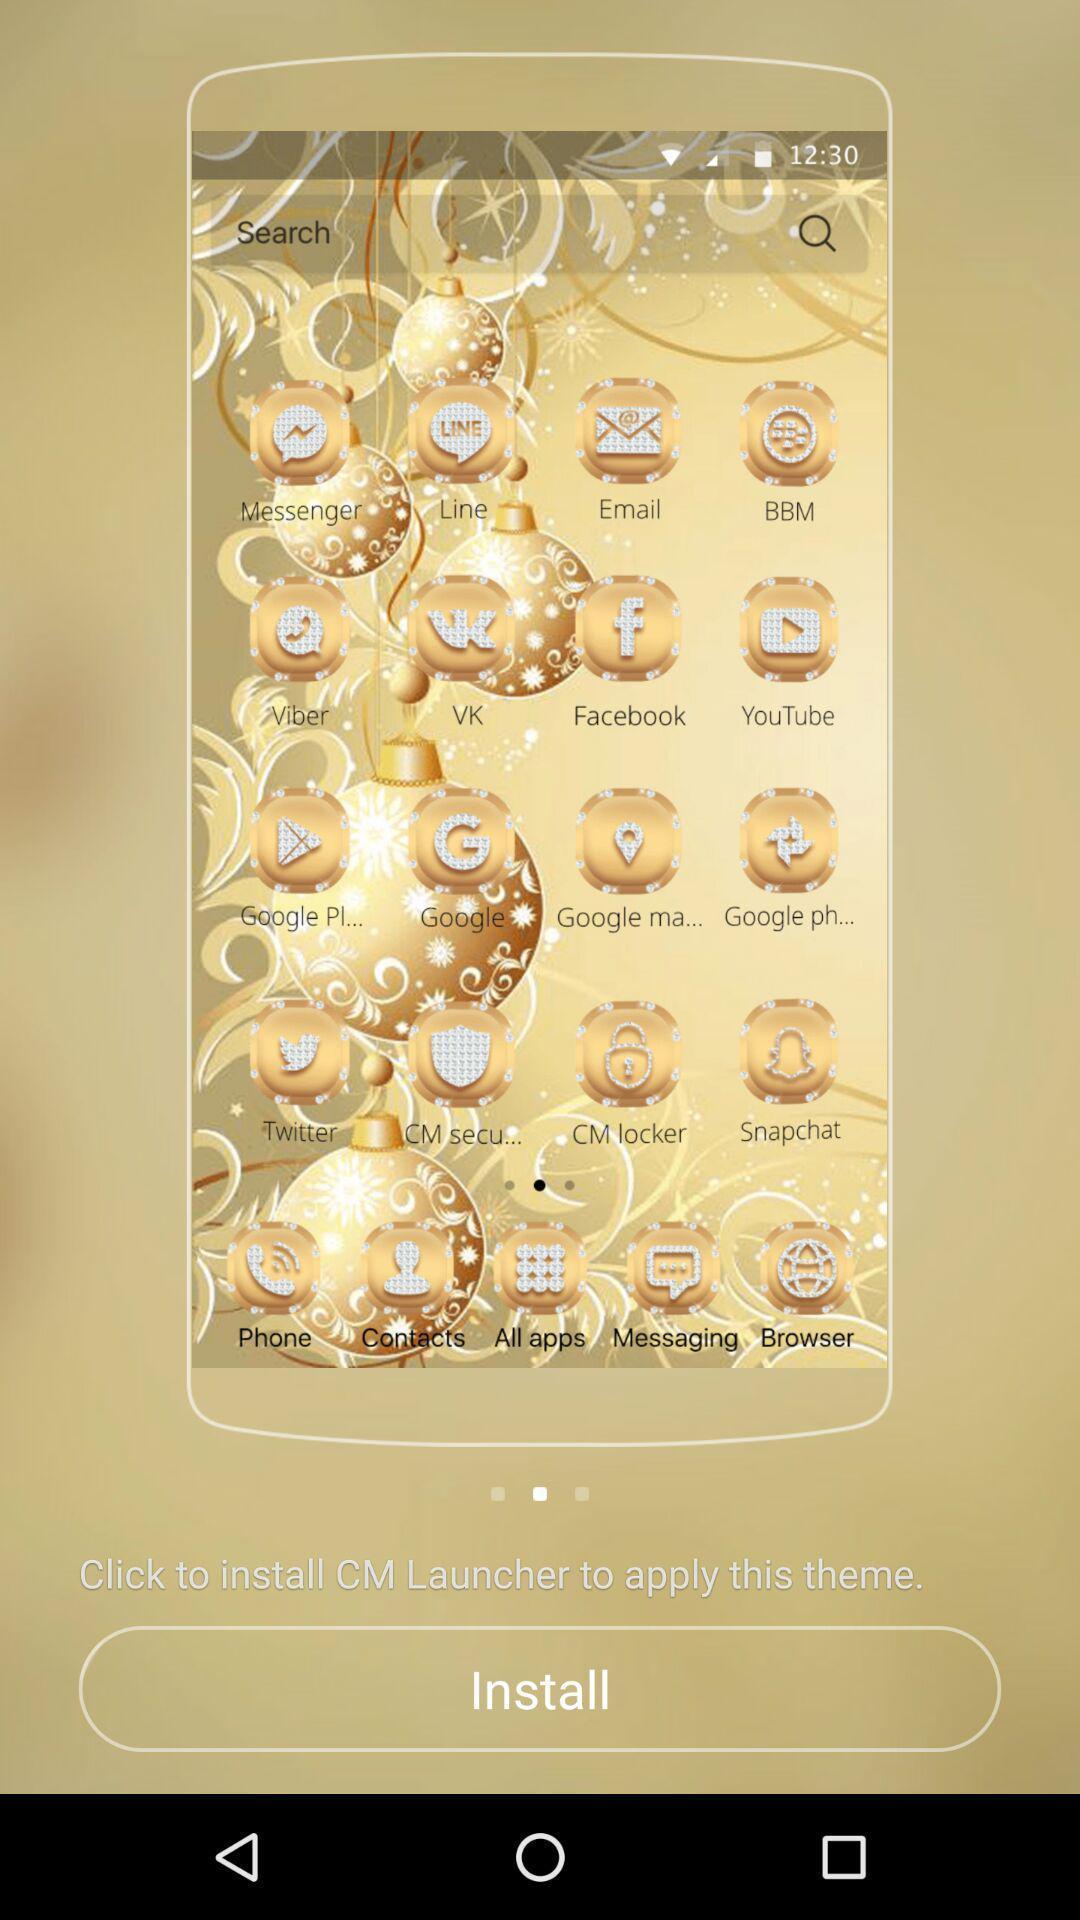Describe the key features of this screenshot. Screen displaying to install an application. 